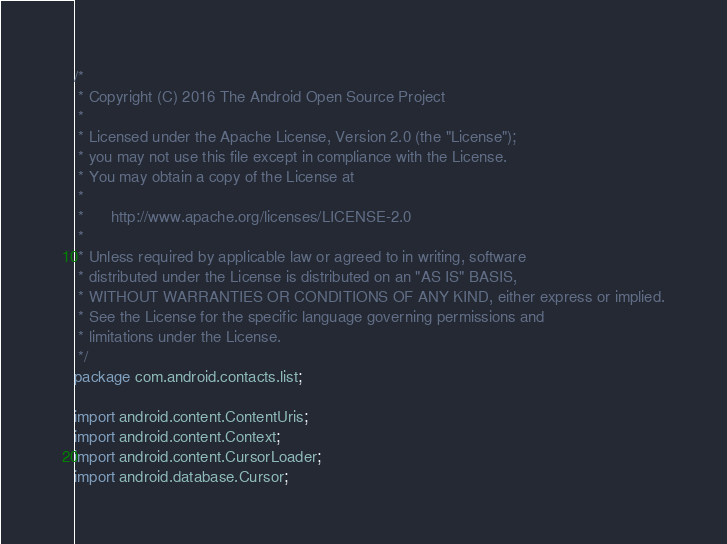Convert code to text. <code><loc_0><loc_0><loc_500><loc_500><_Java_>/*
 * Copyright (C) 2016 The Android Open Source Project
 *
 * Licensed under the Apache License, Version 2.0 (the "License");
 * you may not use this file except in compliance with the License.
 * You may obtain a copy of the License at
 *
 *      http://www.apache.org/licenses/LICENSE-2.0
 *
 * Unless required by applicable law or agreed to in writing, software
 * distributed under the License is distributed on an "AS IS" BASIS,
 * WITHOUT WARRANTIES OR CONDITIONS OF ANY KIND, either express or implied.
 * See the License for the specific language governing permissions and
 * limitations under the License.
 */
package com.android.contacts.list;

import android.content.ContentUris;
import android.content.Context;
import android.content.CursorLoader;
import android.database.Cursor;</code> 